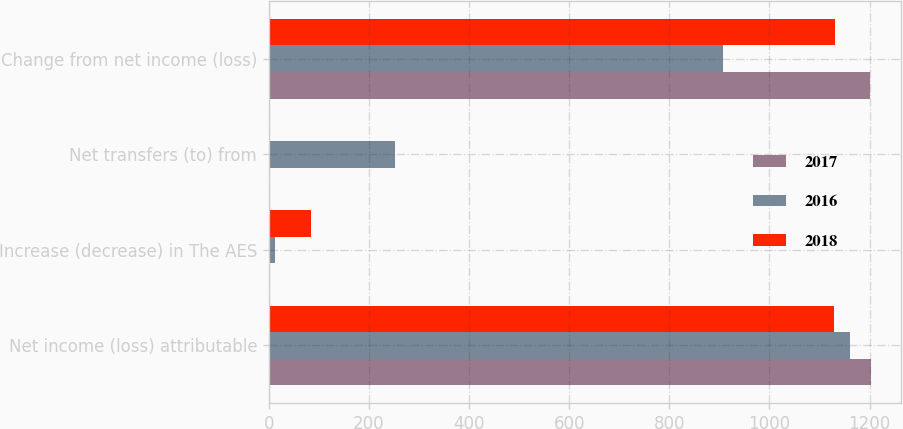Convert chart. <chart><loc_0><loc_0><loc_500><loc_500><stacked_bar_chart><ecel><fcel>Net income (loss) attributable<fcel>Increase (decrease) in The AES<fcel>Net transfers (to) from<fcel>Change from net income (loss)<nl><fcel>2017<fcel>1203<fcel>3<fcel>3<fcel>1200<nl><fcel>2016<fcel>1161<fcel>13<fcel>253<fcel>908<nl><fcel>2018<fcel>1130<fcel>84<fcel>2<fcel>1132<nl></chart> 